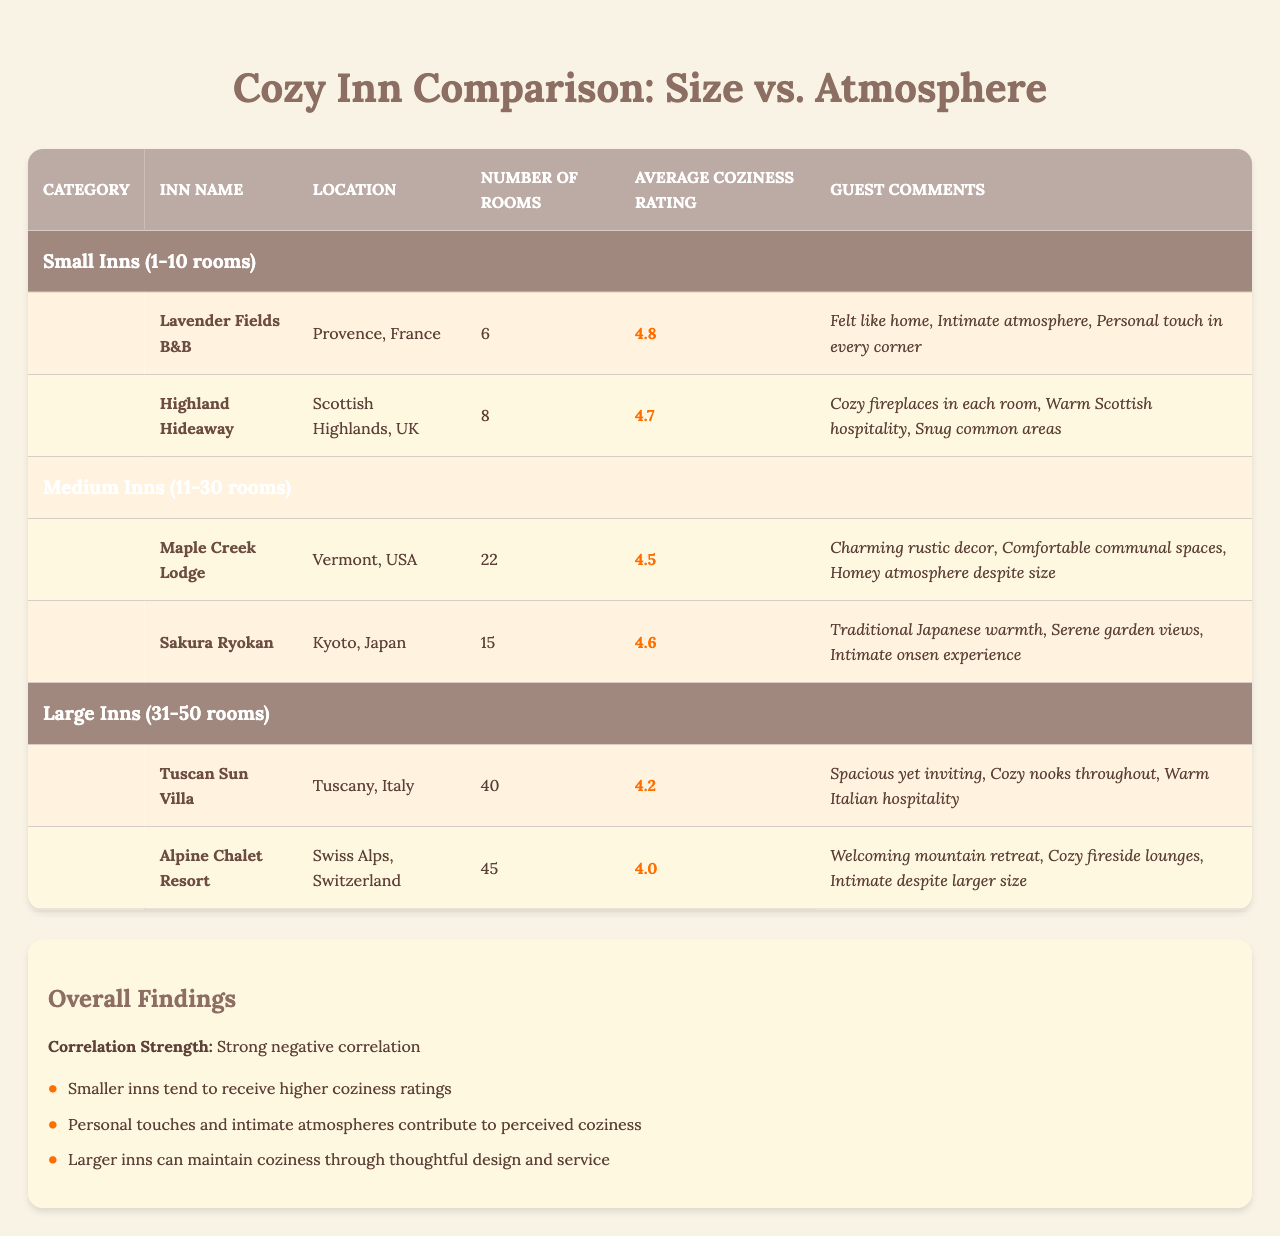What is the average coziness rating for small inns? The table indicates two small inns, Lavender Fields B&B and Highland Hideaway, with ratings of 4.8 and 4.7 respectively. To find the average, sum the ratings: (4.8 + 4.7) = 9.5, then divide by 2: 9.5 / 2 = 4.75.
Answer: 4.75 Which inn has the highest average coziness rating? By reviewing the table, the ratings for the inns are as follows: Lavender Fields B&B (4.8), Highland Hideaway (4.7), Sakura Ryokan (4.6), Maple Creek Lodge (4.5), Tuscan Sun Villa (4.2), and Alpine Chalet Resort (4.0). Lavender Fields B&B has the highest rating at 4.8.
Answer: Lavender Fields B&B Do all the inns listed have average coziness ratings above 4.0? Checking the average ratings in the table, all inns have ratings of 4.0 or higher: Lavender Fields B&B (4.8), Highland Hideaway (4.7), Sakura Ryokan (4.6), Maple Creek Lodge (4.5), Tuscan Sun Villa (4.2), and Alpine Chalet Resort (4.0). Thus, it’s true that all inns meet this criteria.
Answer: Yes What is the difference in average coziness ratings between small and large inns? The average coziness rating for small inns is 4.75, while for large inns it is 4.1 (calculated by averaging Tuscan Sun Villa and Alpine Chalet Resort: (4.2 + 4.0) / 2 = 4.1). The difference is 4.75 - 4.1 = 0.65.
Answer: 0.65 Which medium inn has the lowest average coziness rating? The medium inns listed are Maple Creek Lodge (4.5) and Sakura Ryokan (4.6). Comparing the two, Maple Creek Lodge has the lower rating of 4.5.
Answer: Maple Creek Lodge Is there a noticeable trend in coziness ratings based on inn size categories? Observing the average coziness ratings: Small inns average 4.75, Medium inns average 4.55, and Large inns average 4.1. This suggests a trend where smaller inns tend to have higher ratings, indicating a strong correlation between size and perceived coziness.
Answer: Yes, smaller inns have higher ratings If all guest comments from small inns are combined, how many unique sentiments are expressed? The small inns have the following comments: "Felt like home," "Intimate atmosphere," "Personal touch in every corner" from Lavender Fields B&B and "Cozy fireplaces in each room," "Warm Scottish hospitality," "Snug common areas" from Highland Hideaway. The unique sentiments are: homey feel, intimacy, personal touch, cozy fireplaces, hospitality, and snug areas, totaling 6 unique sentiments.
Answer: 6 How do the guest comments reflect the average coziness ratings for the inns? Analyzing the guest comments, those for higher-rated inns (e.g., Lavender Fields B&B) emphasize personal touch and warmth, whereas lower-rated ones (e.g., Alpine Chalet Resort) focus on spaciousness but lack intimacy. This suggests that more positive, intimate sentiments likely correlate with higher ratings.
Answer: Higher ratings correlate with intimate and warm comments 